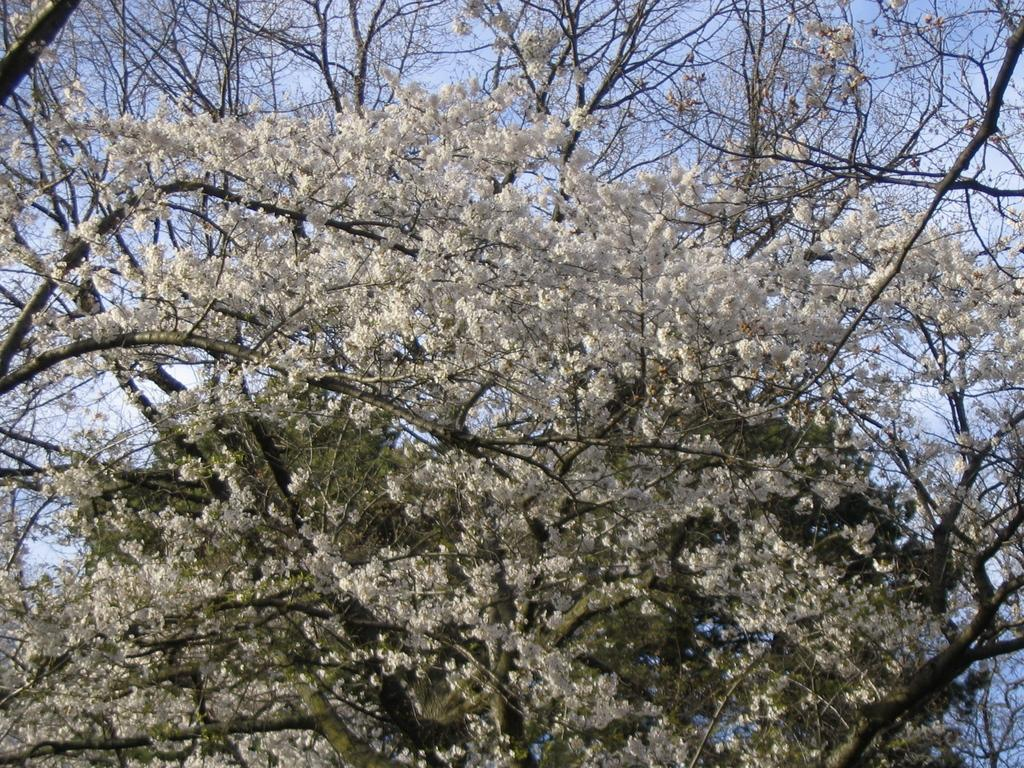What type of vegetation is present in the image? There are trees with flowers in the image. What can be seen in the background of the image? The sky is visible in the background of the image. What type of boundary can be seen in the image? There is no boundary present in the image; it features trees with flowers and a visible sky in the background. Can you tell me how many boats are in the image? There are no boats present in the image. 